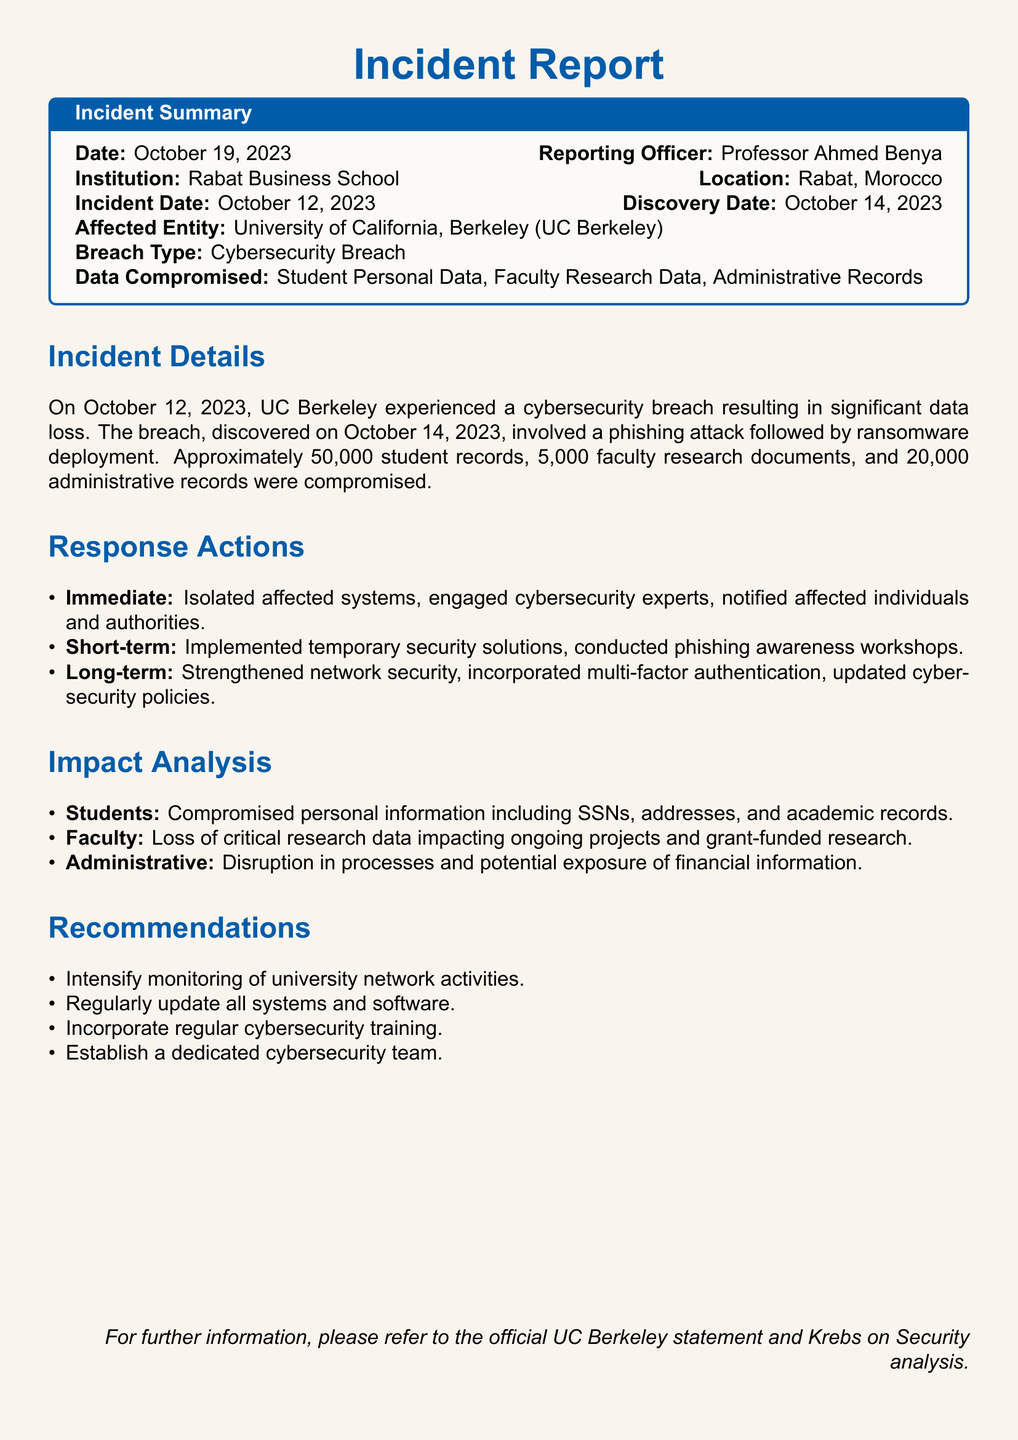What was the incident date? The incident date is specifically mentioned in the document as October 12, 2023.
Answer: October 12, 2023 How many student records were compromised? The document states that approximately 50,000 student records were compromised during the breach.
Answer: 50,000 Who reported the incident? The reporting officer who documented the incident is mentioned as Professor Ahmed Benya.
Answer: Professor Ahmed Benya What type of attack was involved in the breach? The document indicates that the breach involved a phishing attack followed by ransomware deployment.
Answer: Phishing attack What data was compromised from faculty? The incident report specifies that the compromised data includes faculty research documents.
Answer: Faculty research documents What was one of the immediate response actions taken? The document lists immediate response actions, one of which was isolating affected systems.
Answer: Isolated affected systems How many administrative records were compromised? The breach resulted in the compromise of 20,000 administrative records according to the report.
Answer: 20,000 What long-term security measure was recommended? One of the long-term recommendations included incorporating multi-factor authentication.
Answer: Multi-factor authentication Which institution was affected by the breach? The incident report clearly states that the affected entity was the University of California, Berkeley.
Answer: University of California, Berkeley 